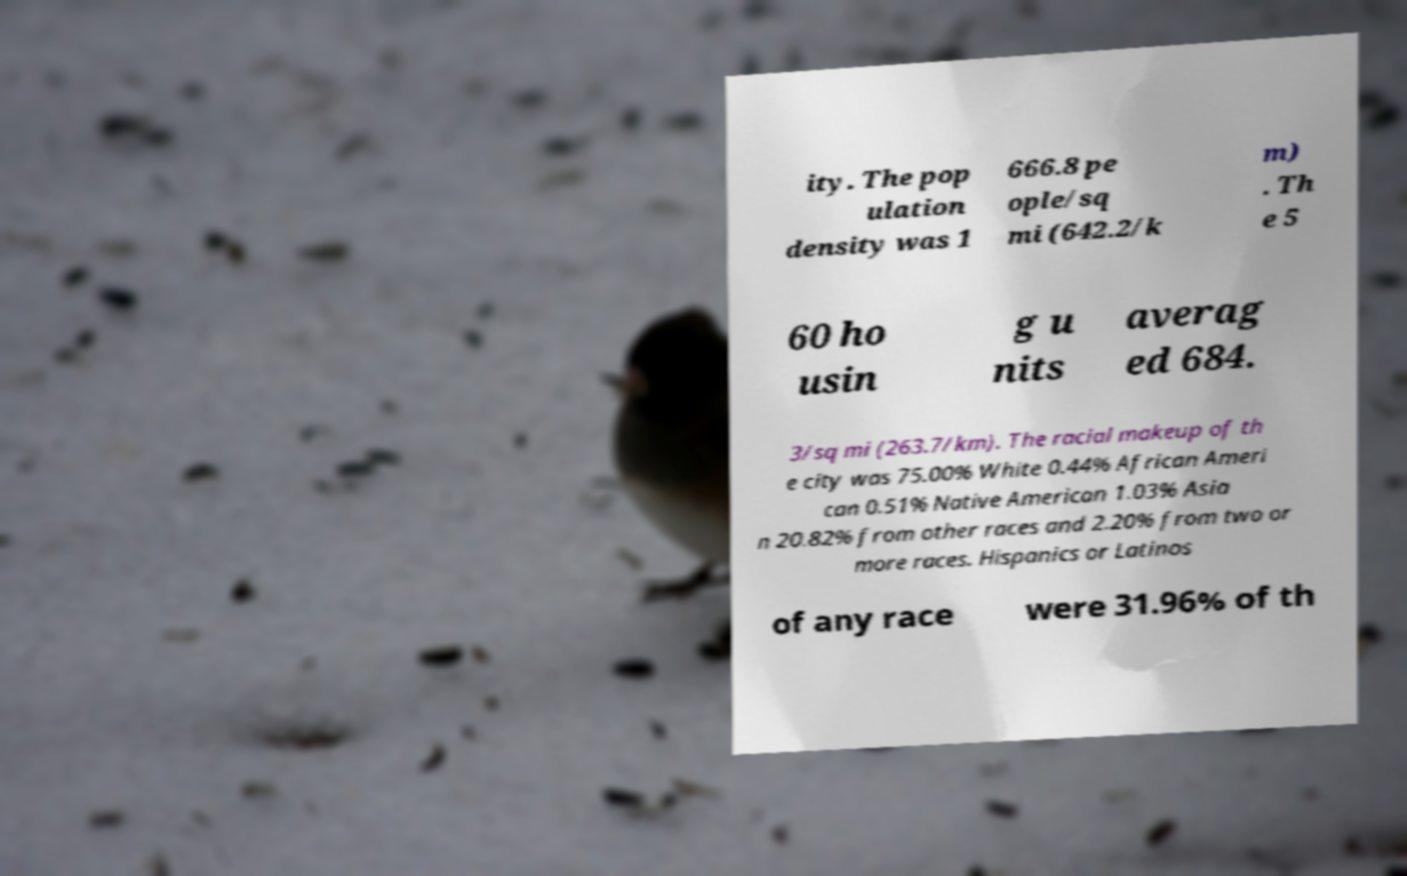Please identify and transcribe the text found in this image. ity. The pop ulation density was 1 666.8 pe ople/sq mi (642.2/k m) . Th e 5 60 ho usin g u nits averag ed 684. 3/sq mi (263.7/km). The racial makeup of th e city was 75.00% White 0.44% African Ameri can 0.51% Native American 1.03% Asia n 20.82% from other races and 2.20% from two or more races. Hispanics or Latinos of any race were 31.96% of th 